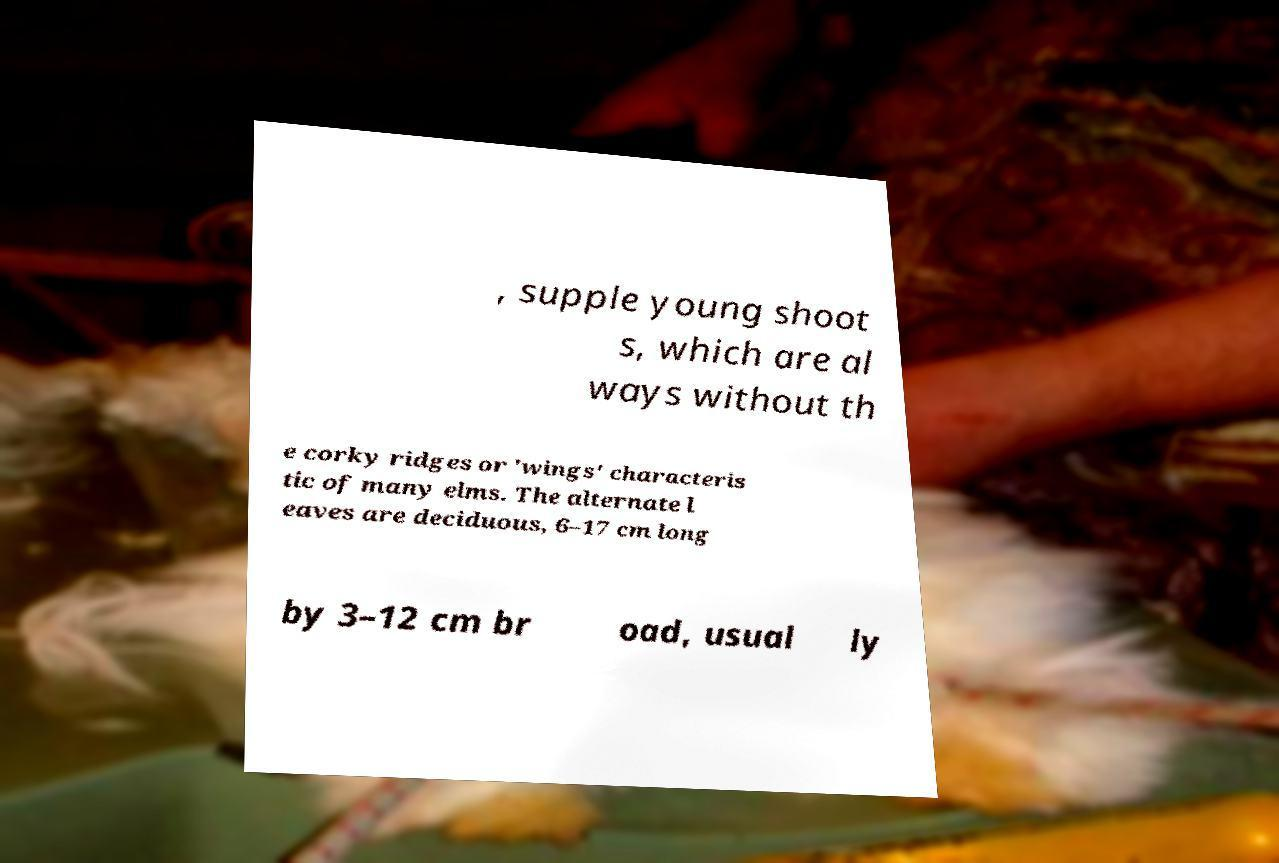Could you assist in decoding the text presented in this image and type it out clearly? , supple young shoot s, which are al ways without th e corky ridges or 'wings' characteris tic of many elms. The alternate l eaves are deciduous, 6–17 cm long by 3–12 cm br oad, usual ly 